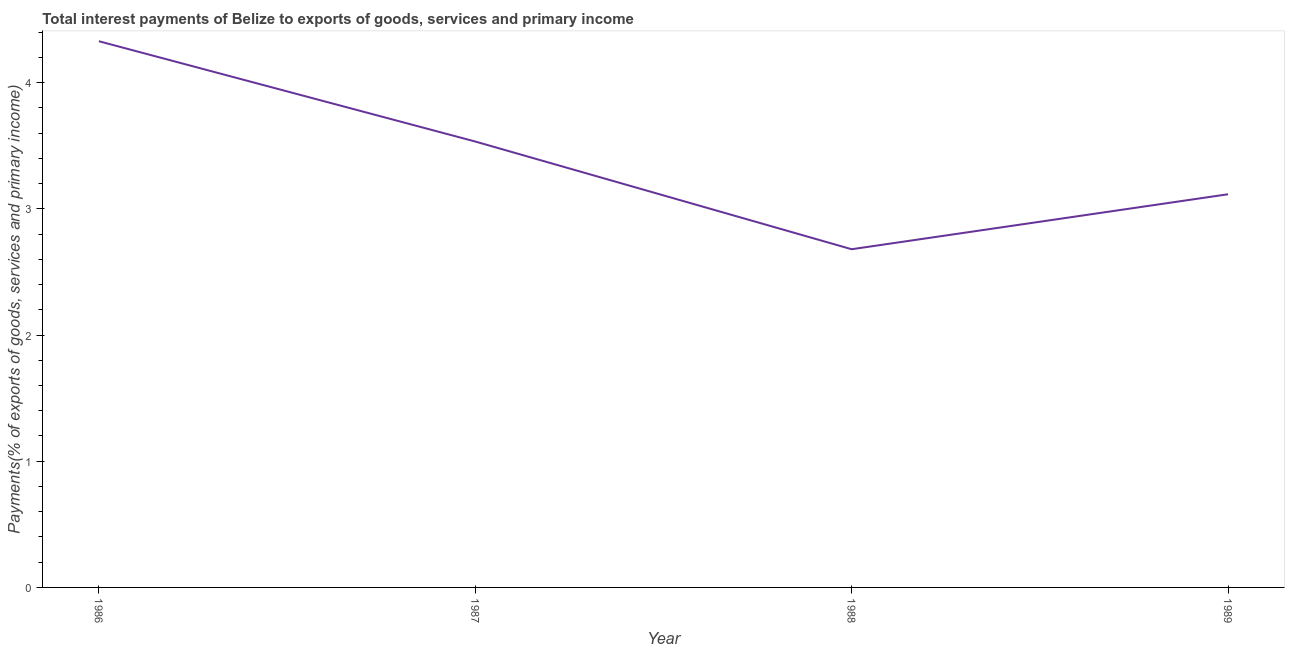What is the total interest payments on external debt in 1989?
Offer a terse response. 3.12. Across all years, what is the maximum total interest payments on external debt?
Your response must be concise. 4.33. Across all years, what is the minimum total interest payments on external debt?
Ensure brevity in your answer.  2.68. In which year was the total interest payments on external debt maximum?
Your answer should be compact. 1986. In which year was the total interest payments on external debt minimum?
Offer a terse response. 1988. What is the sum of the total interest payments on external debt?
Offer a very short reply. 13.66. What is the difference between the total interest payments on external debt in 1987 and 1989?
Make the answer very short. 0.42. What is the average total interest payments on external debt per year?
Ensure brevity in your answer.  3.41. What is the median total interest payments on external debt?
Give a very brief answer. 3.32. What is the ratio of the total interest payments on external debt in 1986 to that in 1988?
Your answer should be compact. 1.62. What is the difference between the highest and the second highest total interest payments on external debt?
Offer a terse response. 0.79. What is the difference between the highest and the lowest total interest payments on external debt?
Your response must be concise. 1.65. In how many years, is the total interest payments on external debt greater than the average total interest payments on external debt taken over all years?
Provide a succinct answer. 2. Does the total interest payments on external debt monotonically increase over the years?
Keep it short and to the point. No. How many lines are there?
Make the answer very short. 1. How many years are there in the graph?
Your response must be concise. 4. Are the values on the major ticks of Y-axis written in scientific E-notation?
Give a very brief answer. No. What is the title of the graph?
Your response must be concise. Total interest payments of Belize to exports of goods, services and primary income. What is the label or title of the X-axis?
Your answer should be very brief. Year. What is the label or title of the Y-axis?
Keep it short and to the point. Payments(% of exports of goods, services and primary income). What is the Payments(% of exports of goods, services and primary income) of 1986?
Provide a succinct answer. 4.33. What is the Payments(% of exports of goods, services and primary income) in 1987?
Ensure brevity in your answer.  3.53. What is the Payments(% of exports of goods, services and primary income) in 1988?
Make the answer very short. 2.68. What is the Payments(% of exports of goods, services and primary income) in 1989?
Your answer should be very brief. 3.12. What is the difference between the Payments(% of exports of goods, services and primary income) in 1986 and 1987?
Your answer should be compact. 0.79. What is the difference between the Payments(% of exports of goods, services and primary income) in 1986 and 1988?
Your response must be concise. 1.65. What is the difference between the Payments(% of exports of goods, services and primary income) in 1986 and 1989?
Ensure brevity in your answer.  1.21. What is the difference between the Payments(% of exports of goods, services and primary income) in 1987 and 1988?
Your response must be concise. 0.85. What is the difference between the Payments(% of exports of goods, services and primary income) in 1987 and 1989?
Your answer should be compact. 0.42. What is the difference between the Payments(% of exports of goods, services and primary income) in 1988 and 1989?
Your response must be concise. -0.44. What is the ratio of the Payments(% of exports of goods, services and primary income) in 1986 to that in 1987?
Your answer should be very brief. 1.23. What is the ratio of the Payments(% of exports of goods, services and primary income) in 1986 to that in 1988?
Your answer should be compact. 1.61. What is the ratio of the Payments(% of exports of goods, services and primary income) in 1986 to that in 1989?
Give a very brief answer. 1.39. What is the ratio of the Payments(% of exports of goods, services and primary income) in 1987 to that in 1988?
Your response must be concise. 1.32. What is the ratio of the Payments(% of exports of goods, services and primary income) in 1987 to that in 1989?
Provide a succinct answer. 1.13. What is the ratio of the Payments(% of exports of goods, services and primary income) in 1988 to that in 1989?
Make the answer very short. 0.86. 